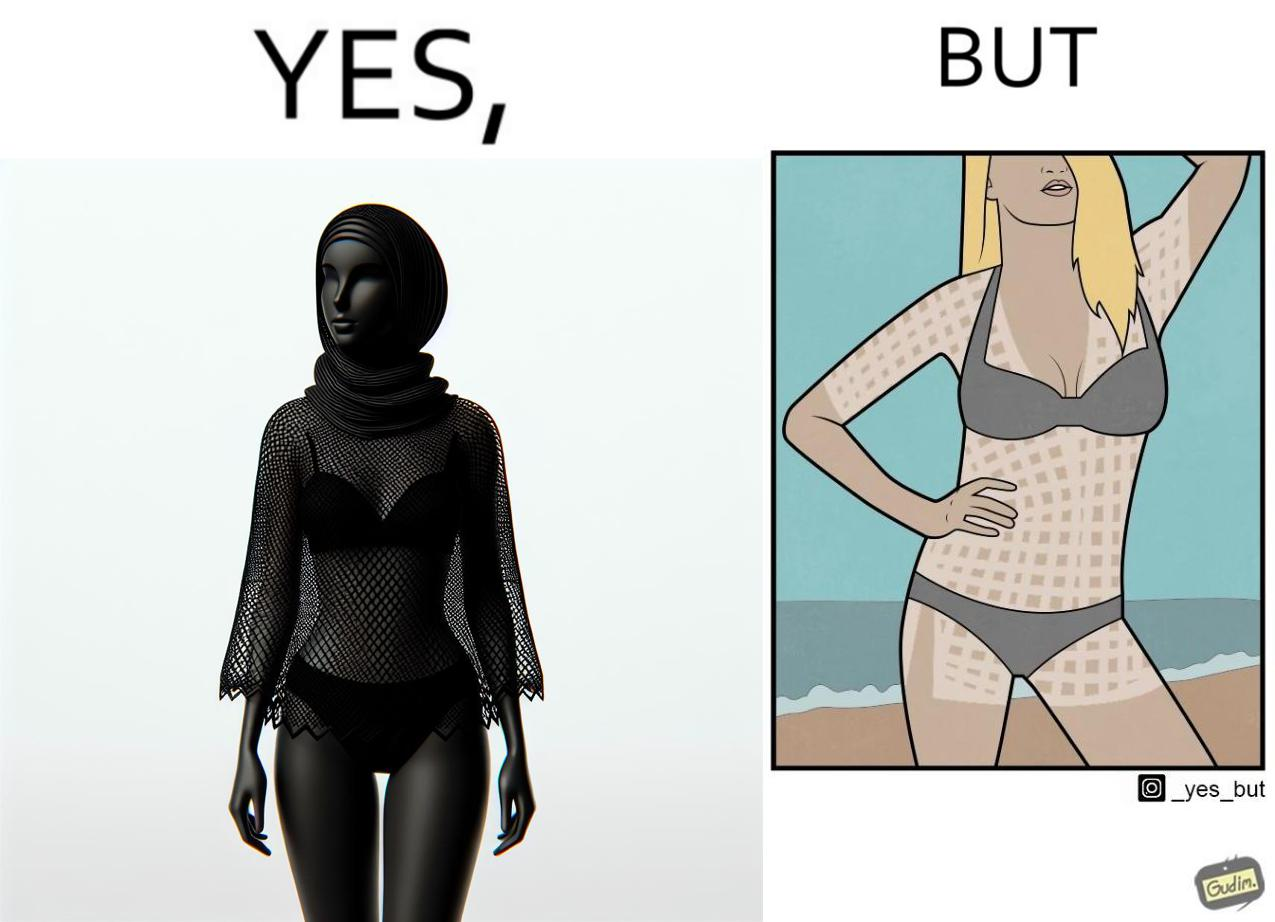Explain the humor or irony in this image. Women wear netted tops while out in the sun on the beach as a beachwear, but when the person removes it, the skin is tanned in the same netted pattern looks weird, and goes against the purpose of using it as beachwear 